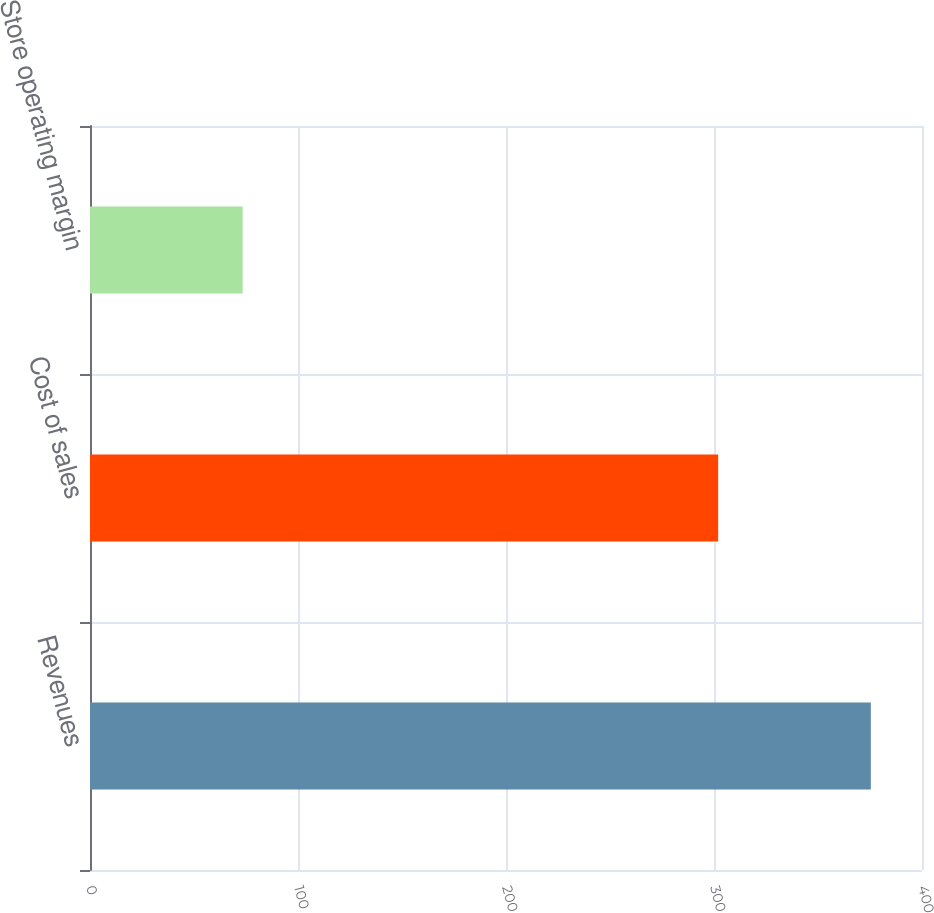Convert chart. <chart><loc_0><loc_0><loc_500><loc_500><bar_chart><fcel>Revenues<fcel>Cost of sales<fcel>Store operating margin<nl><fcel>375.4<fcel>302<fcel>73.4<nl></chart> 